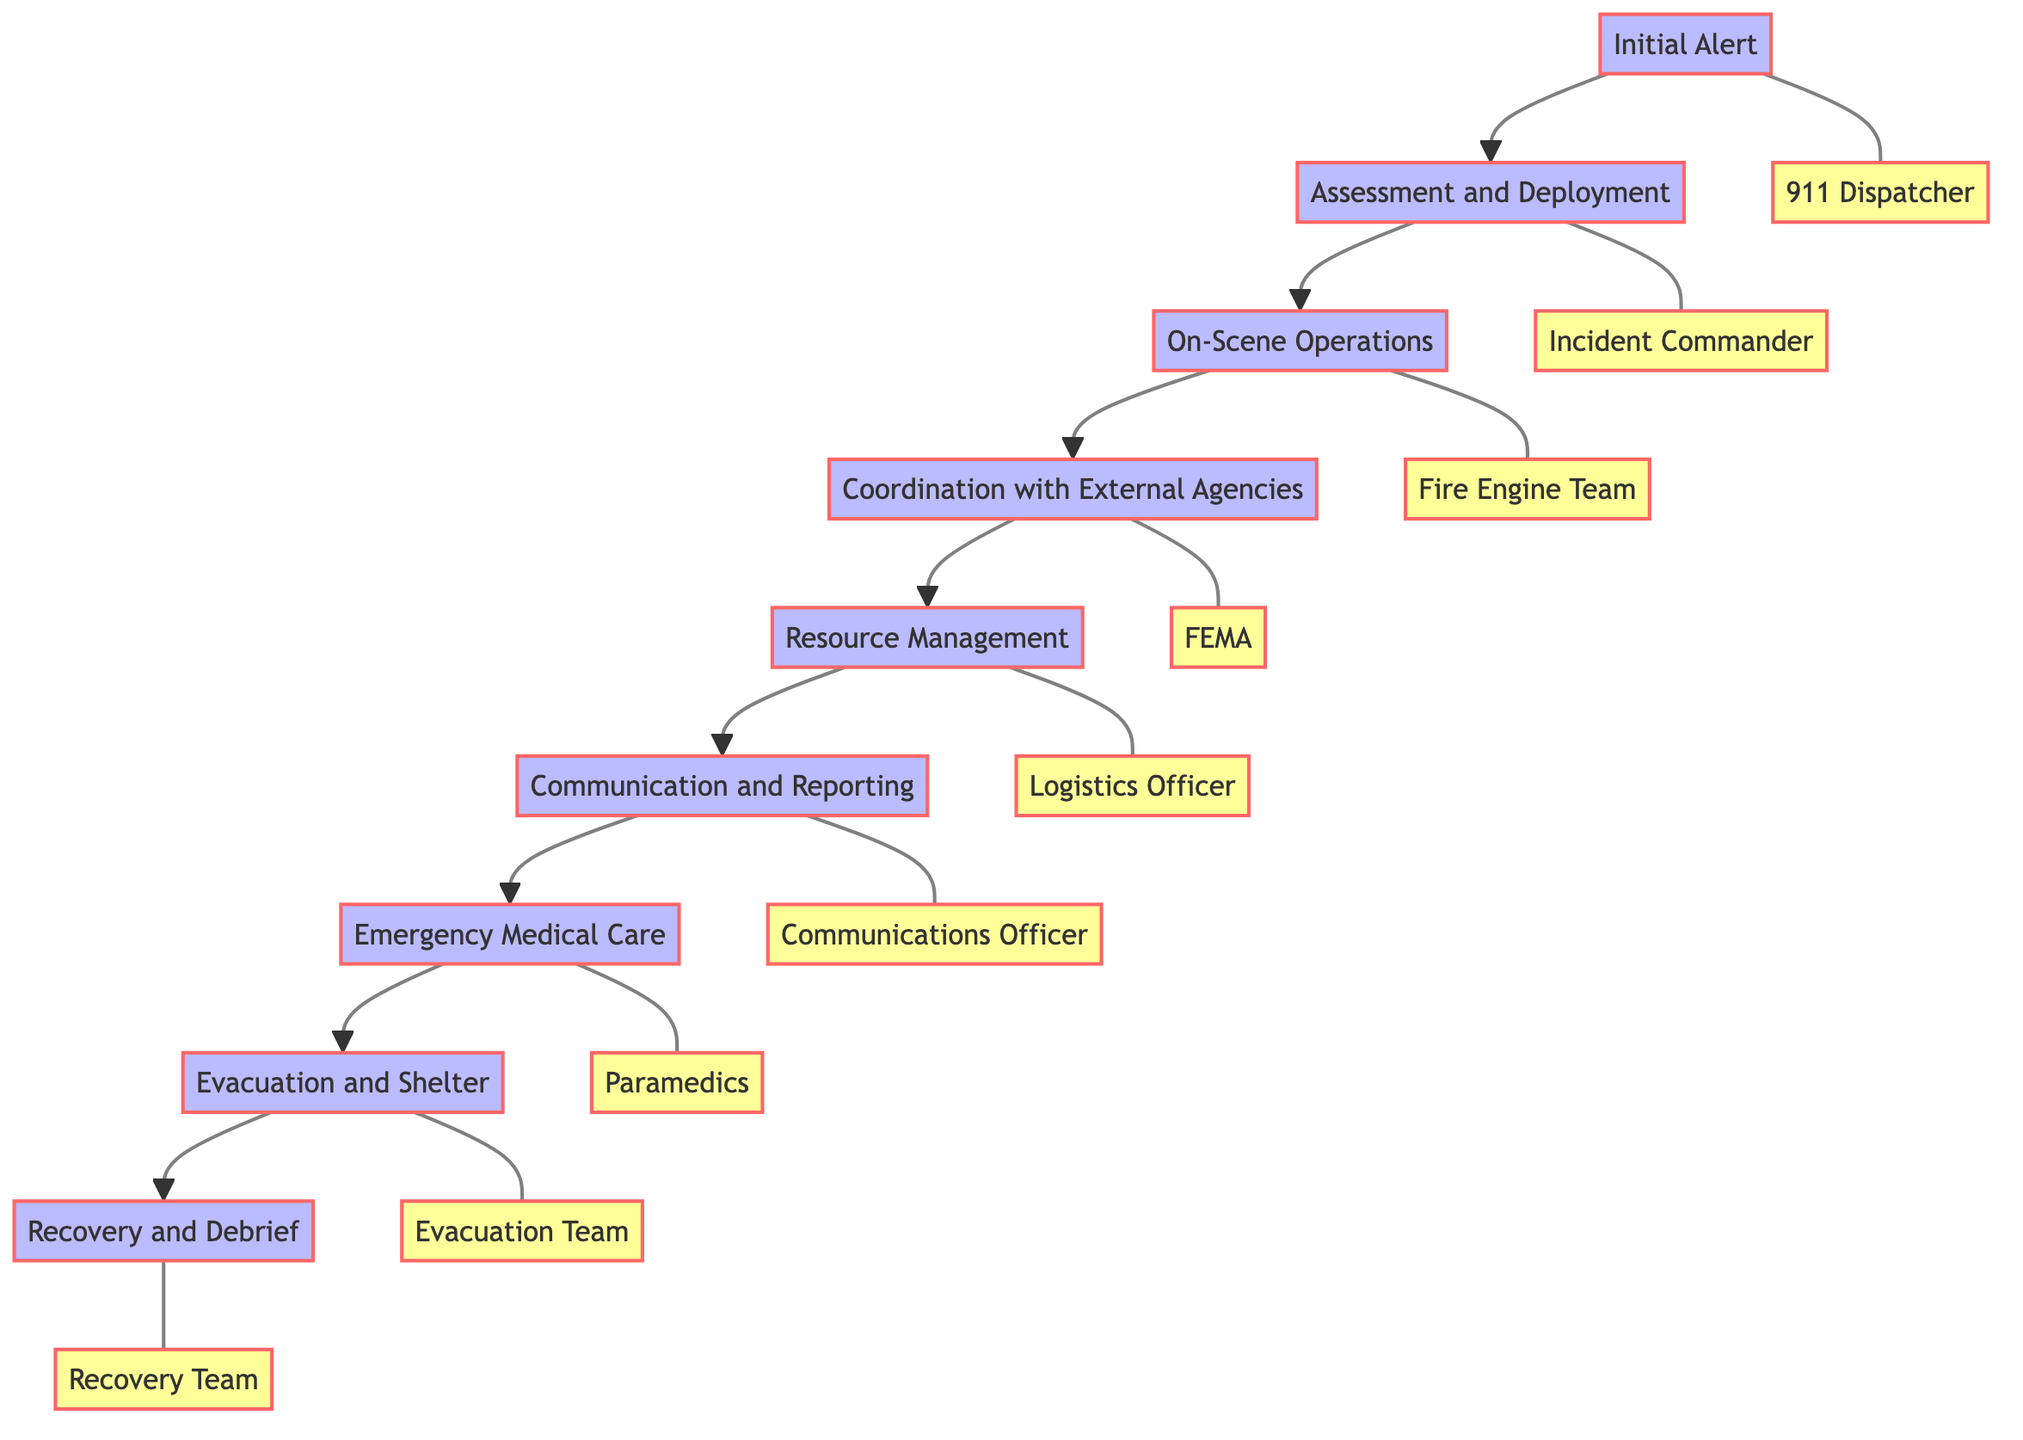What is the first step in the workflow? The first step in the workflow is the "Initial Alert." This is identified as the starting node in the diagram, indicating the commencement of the emergency response process.
Answer: Initial Alert How many nodes are present in the diagram? The diagram consists of 9 key process nodes that illustrate the workflow of the emergency response plan from alert to recovery and debrief.
Answer: 9 Who is responsible for the "Assessment and Deployment"? The entity responsible for the "Assessment and Deployment" is the "Incident Commander." This node is linked directly to the "Assessment and Deployment" step in the diagram.
Answer: Incident Commander Which step includes collaboration with external agencies? The step that includes collaboration with external agencies is "Coordination with External Agencies," as shown in the sequence of the workflow where this step is connected after "On-Scene Operations."
Answer: Coordination with External Agencies What entities are involved in "Emergency Medical Care"? The entities involved in "Emergency Medical Care" are "Paramedics," "Emergency Medical Technicians," and "Hospitals." This can be seen in the details of that specific node describing the medical care provided.
Answer: Paramedics, Emergency Medical Technicians, Hospitals Which step comes directly after "Resource Management"? The step that comes directly after "Resource Management" is "Communication and Reporting." This can be identified by the directional flow shown in the diagram linking these two processes.
Answer: Communication and Reporting What is the purpose of the "Recovery and Debrief" step? The "Recovery and Debrief" step serves the purpose of conducting recovery operations and evaluating the efficacy of the response, as described in the node details of this final step.
Answer: Conduct recovery operations and evaluate response efficacy What is the last step in the emergency response workflow? The last step in the emergency response workflow is "Recovery and Debrief," marking the completion of the process and the evaluation of the entire response. This is clearly positioned as the end node in the flow.
Answer: Recovery and Debrief What does the "Evacuation and Shelter" step involve? The "Evacuation and Shelter" step involves organizing evacuation procedures and setting up temporary shelter for affected individuals, as detailed in that node's description in the diagram.
Answer: Organizing evacuation procedures and temporary shelter 